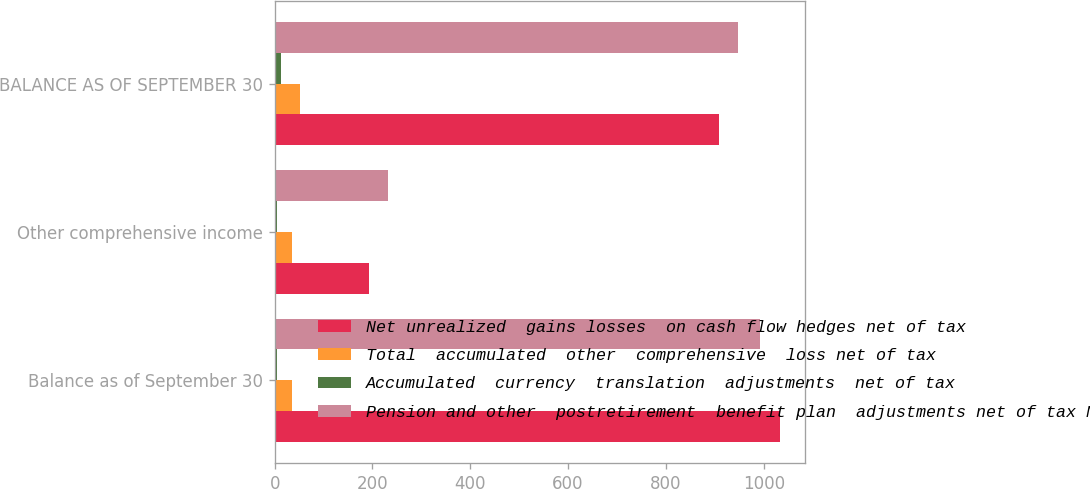<chart> <loc_0><loc_0><loc_500><loc_500><stacked_bar_chart><ecel><fcel>Balance as of September 30<fcel>Other comprehensive income<fcel>BALANCE AS OF SEPTEMBER 30<nl><fcel>Net unrealized  gains losses  on cash flow hedges net of tax<fcel>1033.6<fcel>192.4<fcel>909.4<nl><fcel>Total  accumulated  other  comprehensive  loss net of tax<fcel>35.5<fcel>35<fcel>52.5<nl><fcel>Accumulated  currency  translation  adjustments  net of tax<fcel>5.2<fcel>5<fcel>13.9<nl><fcel>Pension and other  postretirement  benefit plan  adjustments net of tax Note 11<fcel>992.9<fcel>232.4<fcel>948<nl></chart> 